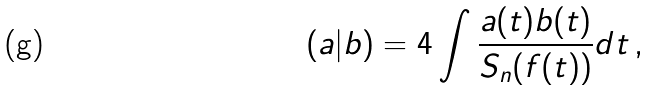<formula> <loc_0><loc_0><loc_500><loc_500>( a | b ) = 4 \int \frac { a ( t ) b ( t ) } { S _ { n } ( f ( t ) ) } d t \, ,</formula> 